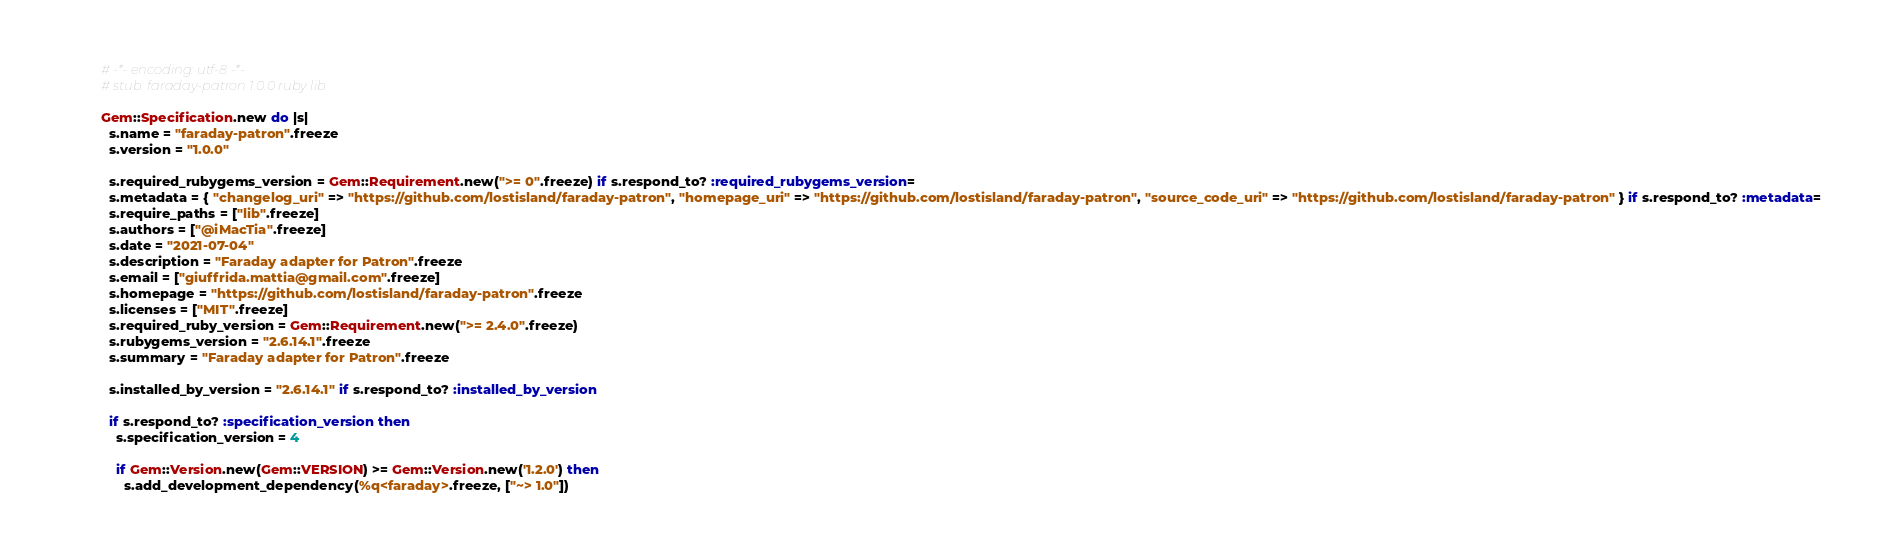<code> <loc_0><loc_0><loc_500><loc_500><_Ruby_># -*- encoding: utf-8 -*-
# stub: faraday-patron 1.0.0 ruby lib

Gem::Specification.new do |s|
  s.name = "faraday-patron".freeze
  s.version = "1.0.0"

  s.required_rubygems_version = Gem::Requirement.new(">= 0".freeze) if s.respond_to? :required_rubygems_version=
  s.metadata = { "changelog_uri" => "https://github.com/lostisland/faraday-patron", "homepage_uri" => "https://github.com/lostisland/faraday-patron", "source_code_uri" => "https://github.com/lostisland/faraday-patron" } if s.respond_to? :metadata=
  s.require_paths = ["lib".freeze]
  s.authors = ["@iMacTia".freeze]
  s.date = "2021-07-04"
  s.description = "Faraday adapter for Patron".freeze
  s.email = ["giuffrida.mattia@gmail.com".freeze]
  s.homepage = "https://github.com/lostisland/faraday-patron".freeze
  s.licenses = ["MIT".freeze]
  s.required_ruby_version = Gem::Requirement.new(">= 2.4.0".freeze)
  s.rubygems_version = "2.6.14.1".freeze
  s.summary = "Faraday adapter for Patron".freeze

  s.installed_by_version = "2.6.14.1" if s.respond_to? :installed_by_version

  if s.respond_to? :specification_version then
    s.specification_version = 4

    if Gem::Version.new(Gem::VERSION) >= Gem::Version.new('1.2.0') then
      s.add_development_dependency(%q<faraday>.freeze, ["~> 1.0"])</code> 